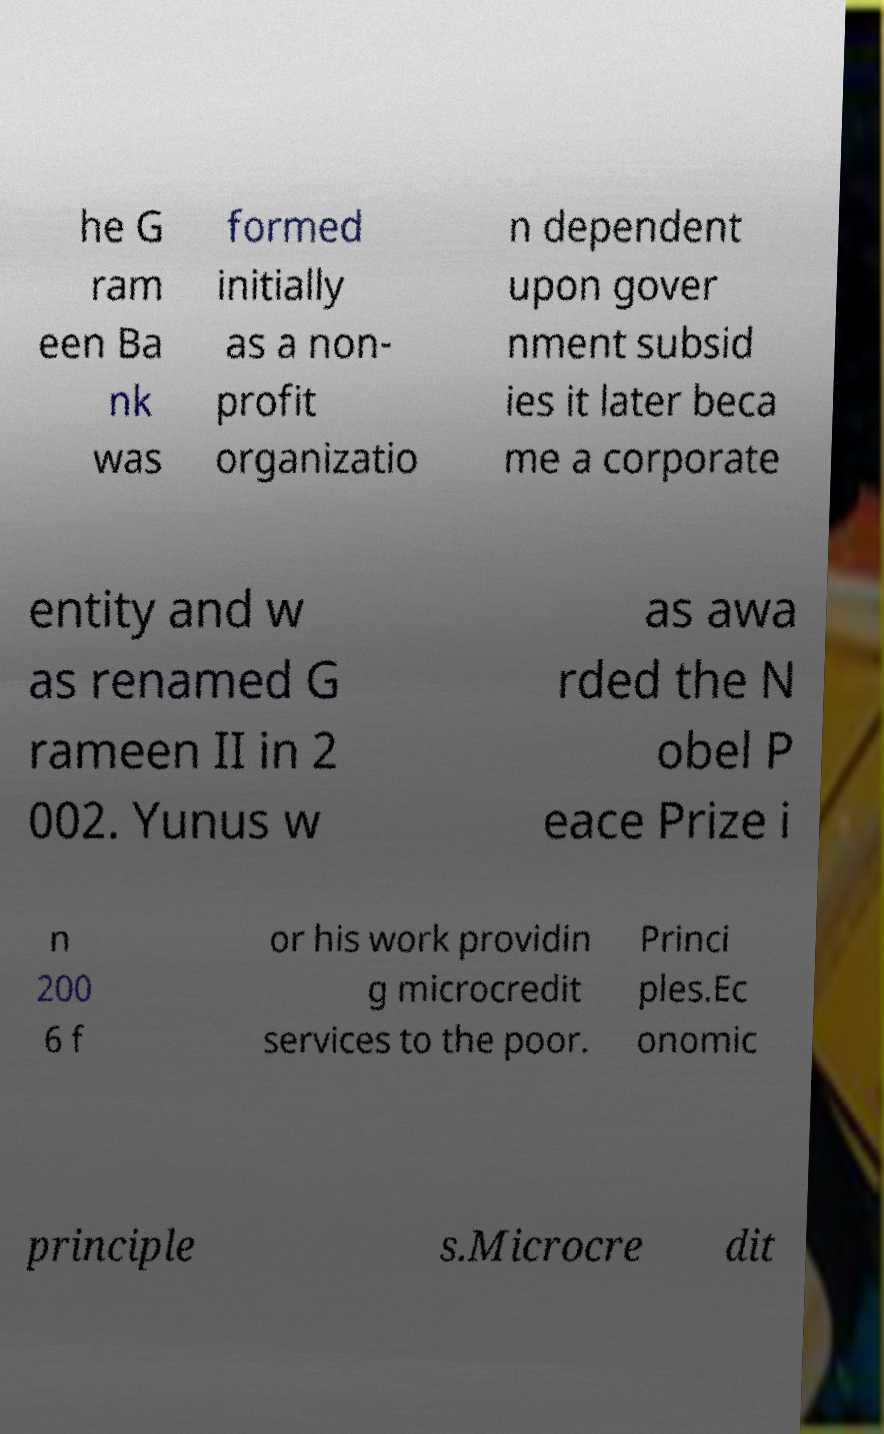For documentation purposes, I need the text within this image transcribed. Could you provide that? he G ram een Ba nk was formed initially as a non- profit organizatio n dependent upon gover nment subsid ies it later beca me a corporate entity and w as renamed G rameen II in 2 002. Yunus w as awa rded the N obel P eace Prize i n 200 6 f or his work providin g microcredit services to the poor. Princi ples.Ec onomic principle s.Microcre dit 